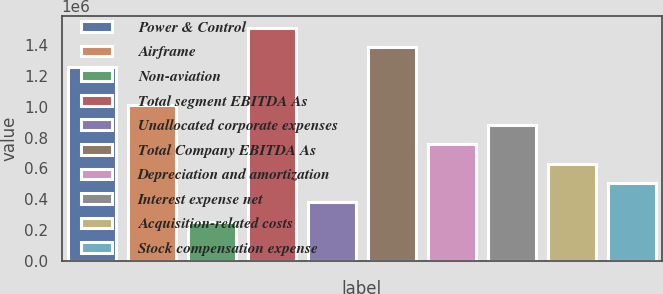Convert chart. <chart><loc_0><loc_0><loc_500><loc_500><bar_chart><fcel>Power & Control<fcel>Airframe<fcel>Non-aviation<fcel>Total segment EBITDA As<fcel>Unallocated corporate expenses<fcel>Total Company EBITDA As<fcel>Depreciation and amortization<fcel>Interest expense net<fcel>Acquisition-related costs<fcel>Stock compensation expense<nl><fcel>1.26093e+06<fcel>1.00909e+06<fcel>253558<fcel>1.51277e+06<fcel>379480<fcel>1.38685e+06<fcel>757243<fcel>883164<fcel>631322<fcel>505401<nl></chart> 